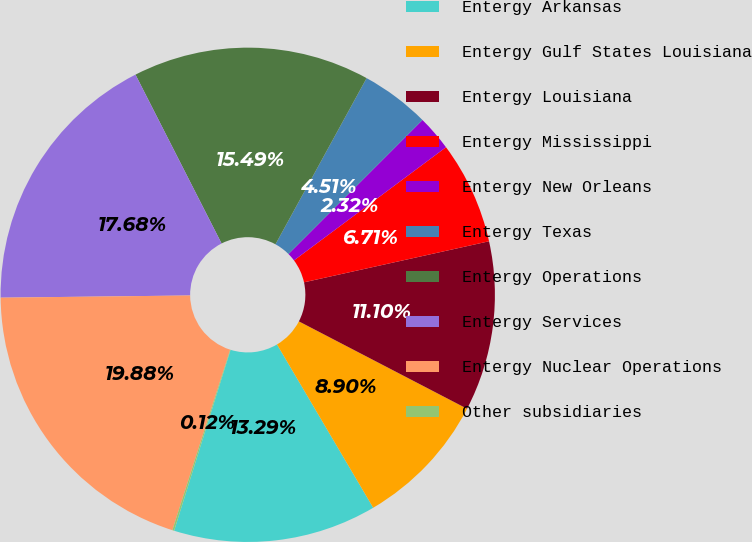<chart> <loc_0><loc_0><loc_500><loc_500><pie_chart><fcel>Entergy Arkansas<fcel>Entergy Gulf States Louisiana<fcel>Entergy Louisiana<fcel>Entergy Mississippi<fcel>Entergy New Orleans<fcel>Entergy Texas<fcel>Entergy Operations<fcel>Entergy Services<fcel>Entergy Nuclear Operations<fcel>Other subsidiaries<nl><fcel>13.29%<fcel>8.9%<fcel>11.1%<fcel>6.71%<fcel>2.32%<fcel>4.51%<fcel>15.49%<fcel>17.68%<fcel>19.88%<fcel>0.12%<nl></chart> 